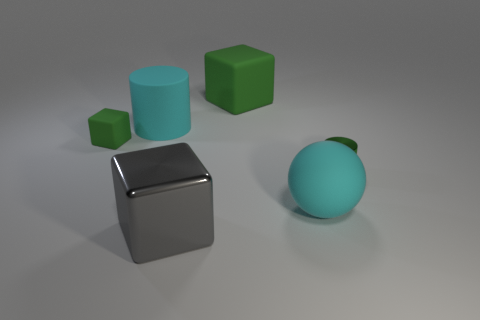Is the shape of the large green matte thing the same as the small green object that is behind the green metal cylinder? The large green object has a cube-like shape with its edges slightly beveled, making them less sharp compared to a perfect cube. The small green object behind the green metal cylinder appears also to have a cubic form, albeit its edges and corners are not visible from this angle, so it could potentially have some beveling as well. Considering this, we can say that both objects share a cubic geometry, with the caveat that slight differences may exist due to the beveling and the perspective hiding the edges of the smaller object. 